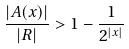Convert formula to latex. <formula><loc_0><loc_0><loc_500><loc_500>\frac { | A ( x ) | } { | R | } > 1 - \frac { 1 } { 2 ^ { | x | } }</formula> 